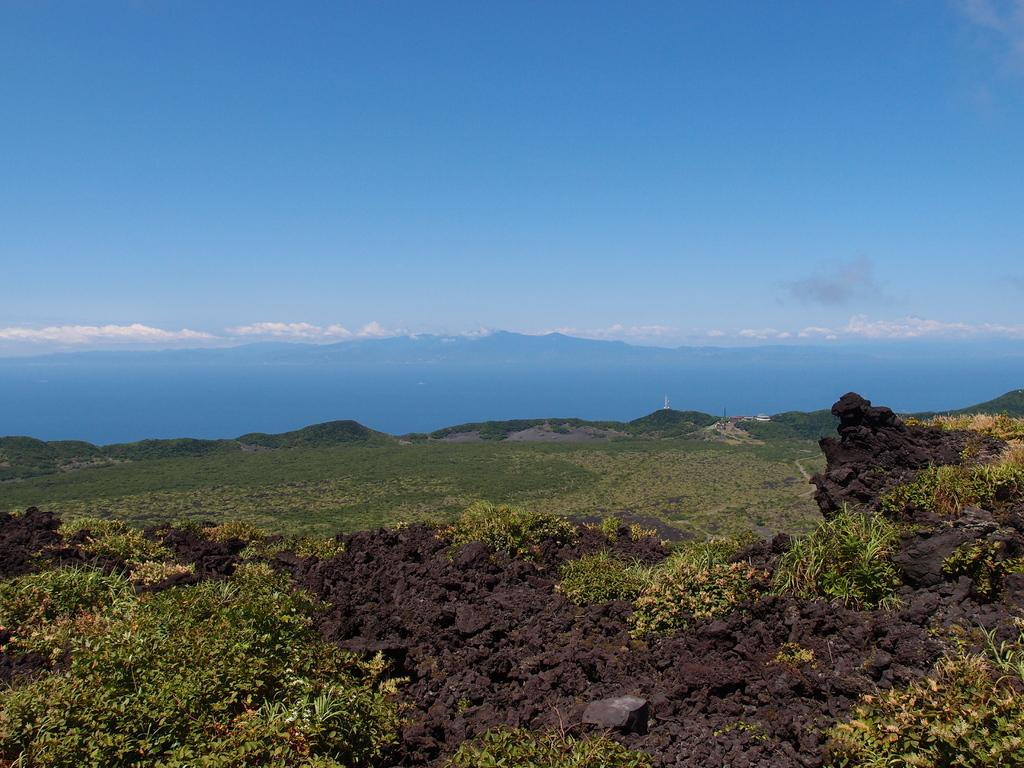What is located at the bottom of the image? There are plants and soil at the bottom of the image. What can be seen in the background of the image? There is sky visible in the background of the image, and there are clouds in the background as well. What type of bread can be seen growing in the soil at the bottom of the image? There is no bread present in the image; it features plants and soil. How many seeds can be seen sprouting from the basket in the image? There is no basket present in the image, so it is not possible to determine the number of seeds. 